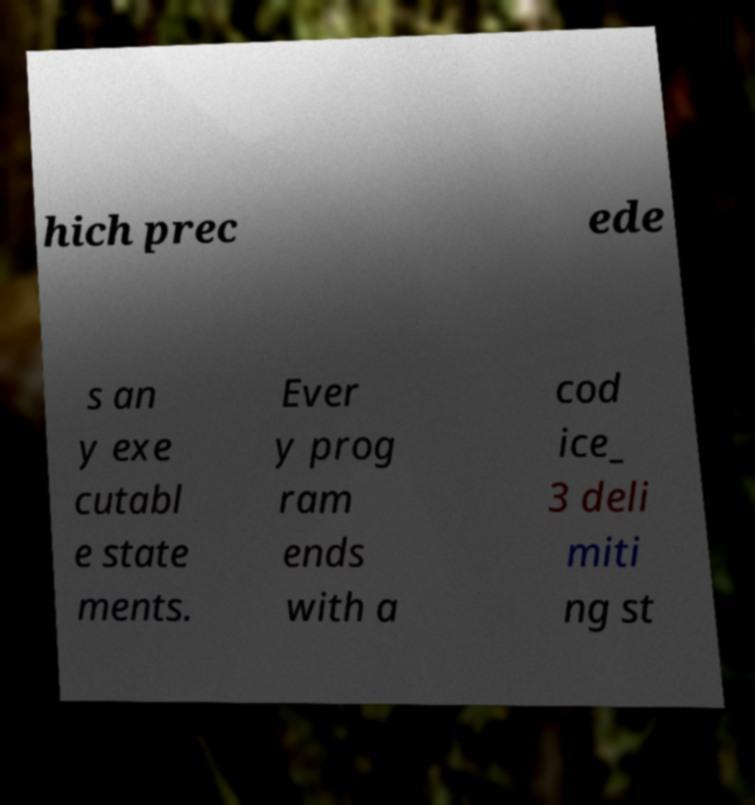What messages or text are displayed in this image? I need them in a readable, typed format. hich prec ede s an y exe cutabl e state ments. Ever y prog ram ends with a cod ice_ 3 deli miti ng st 